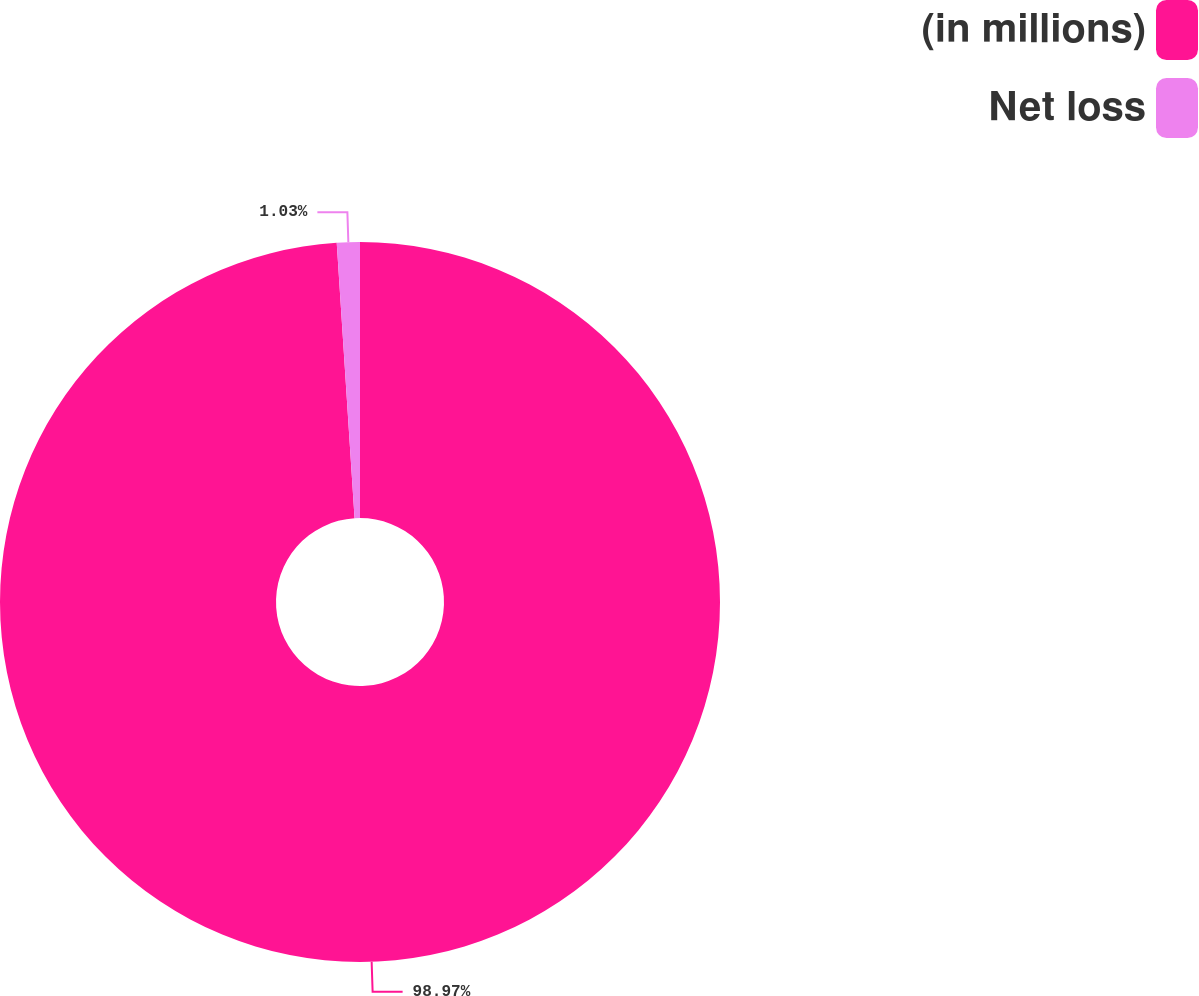<chart> <loc_0><loc_0><loc_500><loc_500><pie_chart><fcel>(in millions)<fcel>Net loss<nl><fcel>98.97%<fcel>1.03%<nl></chart> 